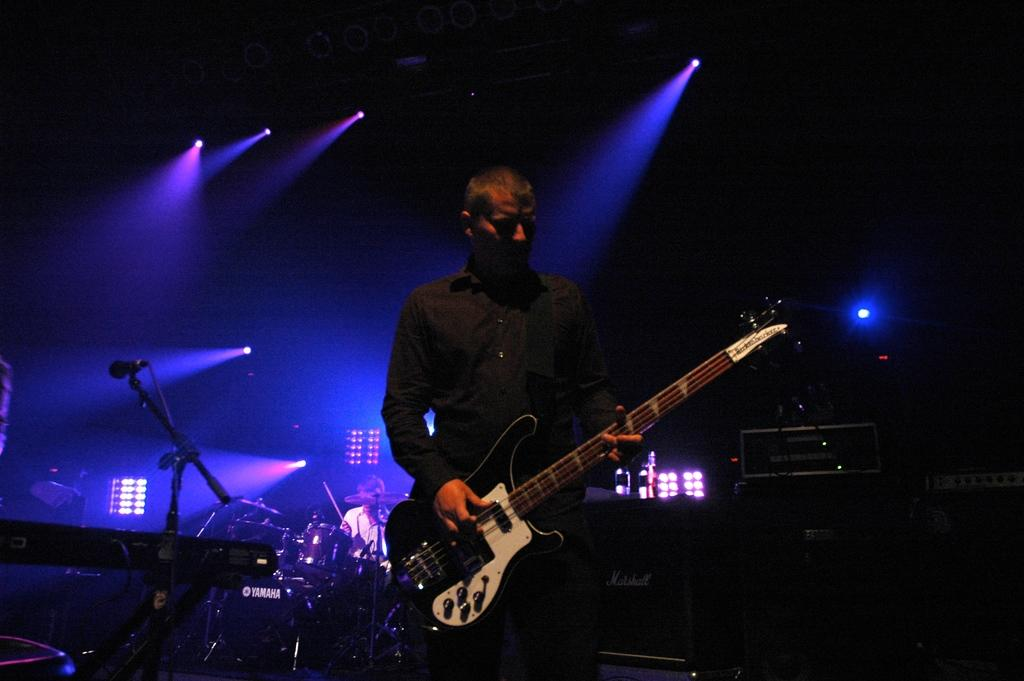What is the man in the image doing? The man is standing in the image and holding a guitar in his hands. What other musical instruments can be seen in the image? There are musical drums in the background of the image. What can be seen illuminating the scene in the image? There are lights visible in the image. What type of stocking is the man wearing on his guitar in the image? There is no stocking present on the guitar in the image. Can you see a plane flying in the background of the image? There is no plane visible in the image. Is there a bee buzzing around the man's head in the image? There is no bee present in the image. 